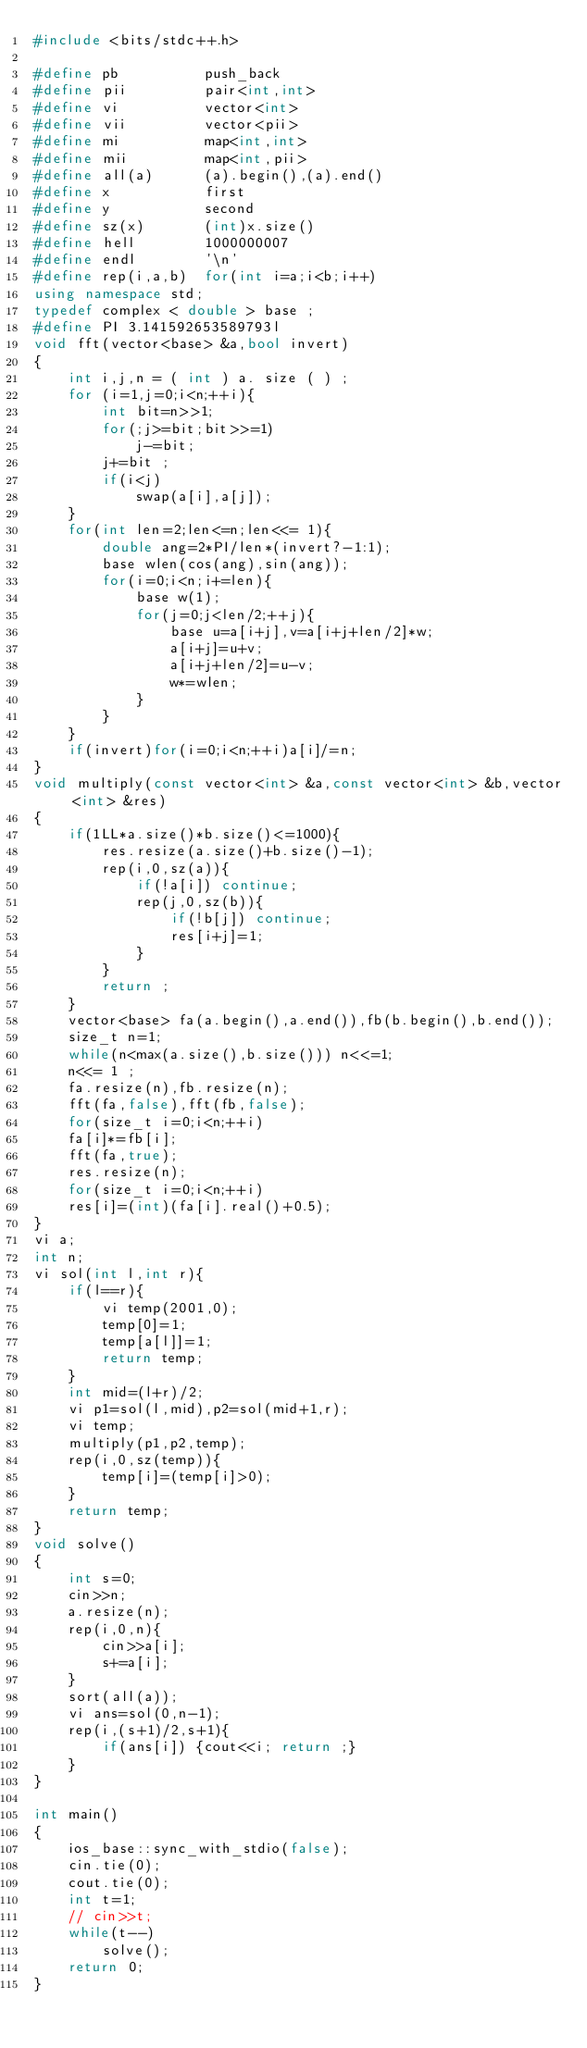Convert code to text. <code><loc_0><loc_0><loc_500><loc_500><_C++_>#include <bits/stdc++.h>

#define pb          push_back
#define pii         pair<int,int>
#define vi          vector<int>
#define vii         vector<pii>
#define mi          map<int,int>
#define mii         map<int,pii>    
#define all(a)      (a).begin(),(a).end()
#define x           first
#define y           second
#define sz(x)       (int)x.size()
#define hell        1000000007
#define endl        '\n'
#define rep(i,a,b)  for(int i=a;i<b;i++)
using namespace std;
typedef complex < double > base ;
#define PI 3.141592653589793l
void fft(vector<base> &a,bool invert)
{
    int i,j,n = ( int ) a. size ( ) ;
    for (i=1,j=0;i<n;++i){
        int bit=n>>1;
        for(;j>=bit;bit>>=1)
            j-=bit;
        j+=bit ;
        if(i<j)
            swap(a[i],a[j]);
    }
    for(int len=2;len<=n;len<<= 1){
        double ang=2*PI/len*(invert?-1:1);
        base wlen(cos(ang),sin(ang));
        for(i=0;i<n;i+=len){
            base w(1);
            for(j=0;j<len/2;++j){
                base u=a[i+j],v=a[i+j+len/2]*w;
                a[i+j]=u+v;
                a[i+j+len/2]=u-v;
                w*=wlen;
            }
        }
    }
    if(invert)for(i=0;i<n;++i)a[i]/=n;
}
void multiply(const vector<int> &a,const vector<int> &b,vector <int> &res)
{
    if(1LL*a.size()*b.size()<=1000){
        res.resize(a.size()+b.size()-1);
        rep(i,0,sz(a)){
            if(!a[i]) continue;
            rep(j,0,sz(b)){
                if(!b[j]) continue;
                res[i+j]=1;
            }
        }
        return ;
    }
    vector<base> fa(a.begin(),a.end()),fb(b.begin(),b.end());
    size_t n=1;
    while(n<max(a.size(),b.size())) n<<=1;
    n<<= 1 ;
    fa.resize(n),fb.resize(n);
    fft(fa,false),fft(fb,false);
    for(size_t i=0;i<n;++i)
    fa[i]*=fb[i];
    fft(fa,true);
    res.resize(n);
    for(size_t i=0;i<n;++i)
    res[i]=(int)(fa[i].real()+0.5);
}
vi a;
int n;
vi sol(int l,int r){
    if(l==r){
        vi temp(2001,0);
        temp[0]=1;
        temp[a[l]]=1;
        return temp;
    }
    int mid=(l+r)/2;
    vi p1=sol(l,mid),p2=sol(mid+1,r);
    vi temp;
    multiply(p1,p2,temp);
    rep(i,0,sz(temp)){
        temp[i]=(temp[i]>0);
    }
    return temp;
}
void solve()
{
    int s=0;
    cin>>n;
    a.resize(n);
    rep(i,0,n){
        cin>>a[i];
        s+=a[i];
    }
    sort(all(a));
    vi ans=sol(0,n-1);
    rep(i,(s+1)/2,s+1){
        if(ans[i]) {cout<<i; return ;}
    }
}

int main()
{
    ios_base::sync_with_stdio(false);
    cin.tie(0);
    cout.tie(0);
    int t=1;
    // cin>>t;
    while(t--)
        solve();
    return 0;
}</code> 